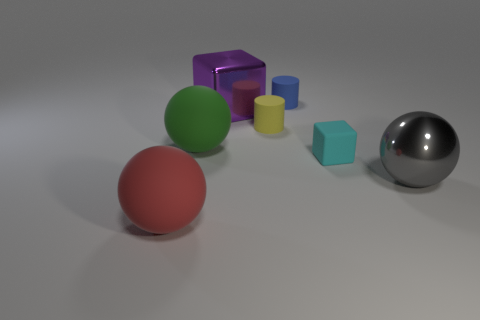The matte thing that is behind the big object that is behind the big green object is what color?
Give a very brief answer. Blue. What number of small things are either rubber objects or cyan blocks?
Offer a very short reply. 3. What material is the large red object that is the same shape as the gray shiny thing?
Your answer should be compact. Rubber. Is there any other thing that has the same material as the purple thing?
Your answer should be compact. Yes. The tiny cube has what color?
Keep it short and to the point. Cyan. Is the matte cube the same color as the shiny ball?
Provide a short and direct response. No. There is a shiny thing that is in front of the tiny cyan cube; what number of large purple shiny objects are in front of it?
Make the answer very short. 0. There is a matte object that is on the right side of the yellow matte thing and in front of the big purple metallic block; how big is it?
Give a very brief answer. Small. There is a thing left of the green object; what is it made of?
Your answer should be compact. Rubber. Is there a red metallic thing of the same shape as the big purple thing?
Ensure brevity in your answer.  No. 